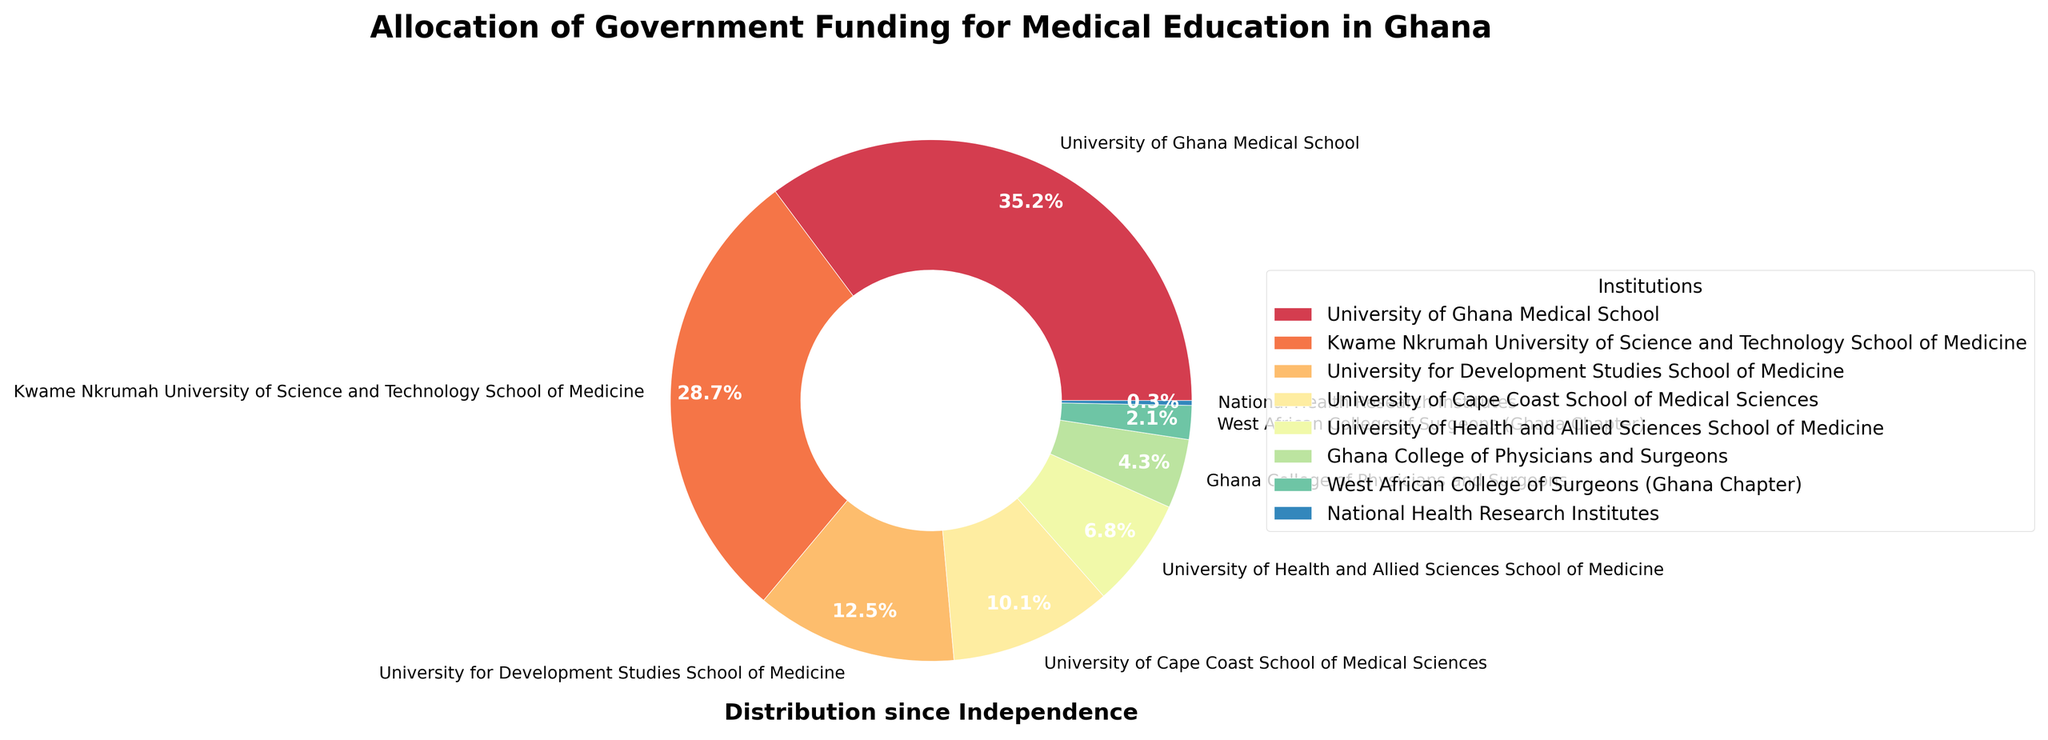Which institution receives the largest share of government funding? By looking at the slices of the pie chart, the University of Ghana Medical School has the largest visible portion.
Answer: University of Ghana Medical School Which two institutions combined receive over half of the government's funding? Adding the percentages for University of Ghana Medical School (35.2%) and Kwame Nkrumah University of Science and Technology School of Medicine (28.7%) gives 63.9%, which is more than half.
Answer: University of Ghana Medical School and Kwame Nkrumah University of Science and Technology School of Medicine How much more funding does the University of Ghana Medical School receive compared to the University for Development Studies School of Medicine? Subtract the percentage for University for Development Studies School of Medicine (12.5%) from University of Ghana Medical School (35.2%) to get the difference, 35.2% - 12.5% = 22.7%.
Answer: 22.7% What is the percentage of funding allocated to institutions other than the University of Ghana Medical School and Kwame Nkrumah University of Science and Technology School of Medicine? Subtract the combined percentage of University of Ghana Medical School (35.2%) and Kwame Nkrumah University of Science and Technology School of Medicine (28.7%) from 100%, so 100% - 63.9% = 36.1%.
Answer: 36.1% Which institution receives the least amount of government funding? By comparing the sizes of the slices, the National Health Research Institutes has the smallest proportion in the pie chart.
Answer: National Health Research Institutes If the funding to University of Cape Coast School of Medical Sciences were doubled, would it then surpass the funding of Kwame Nkrumah University of Science and Technology School of Medicine? Doubling the percentage for University of Cape Coast School of Medical Sciences (10.1% * 2 = 20.2%) would still be less than the funding for Kwame Nkrumah University of Science and Technology School of Medicine (28.7%).
Answer: No Between Ghana College of Physicians and Surgeons and West African College of Surgeons (Ghana Chapter), which institution receives more funding? By comparing their slices, the Ghana College of Physicians and Surgeons (4.3%) has a larger percentage than the West African College of Surgeons (Ghana Chapter) (2.1%).
Answer: Ghana College of Physicians and Surgeons What is the combined funding percentage for the University of Health and Allied Sciences School of Medicine and Ghana College of Physicians and Surgeons? Add the percentage for University of Health and Allied Sciences School of Medicine (6.8%) and Ghana College of Physicians and Surgeons (4.3%) to get 6.8% + 4.3% = 11.1%.
Answer: 11.1% What portion of the funding pie chart belongs to institutions with less than 10% funding? Summing up the percentages of institutions with less than 10% funding (University of Cape Coast School of Medical Sciences (10.1%), University of Health and Allied Sciences School of Medicine (6.8%), Ghana College of Physicians and Surgeons (4.3%), West African College of Surgeons (Ghana Chapter) (2.1%), National Health Research Institutes (0.3%)) gives 10.1% + 6.8% + 4.3% + 2.1% + 0.3% = 23.6%.
Answer: 23.6% Which institution's funding is closest to 10% but not over? By looking at the slices slightly below 10%, University of Cape Coast School of Medical Sciences gets 10.1%, which is just over 10%, so University of Health and Allied Sciences School of Medicine at 6.8% is closest but not over.
Answer: University of Health and Allied Sciences School of Medicine 